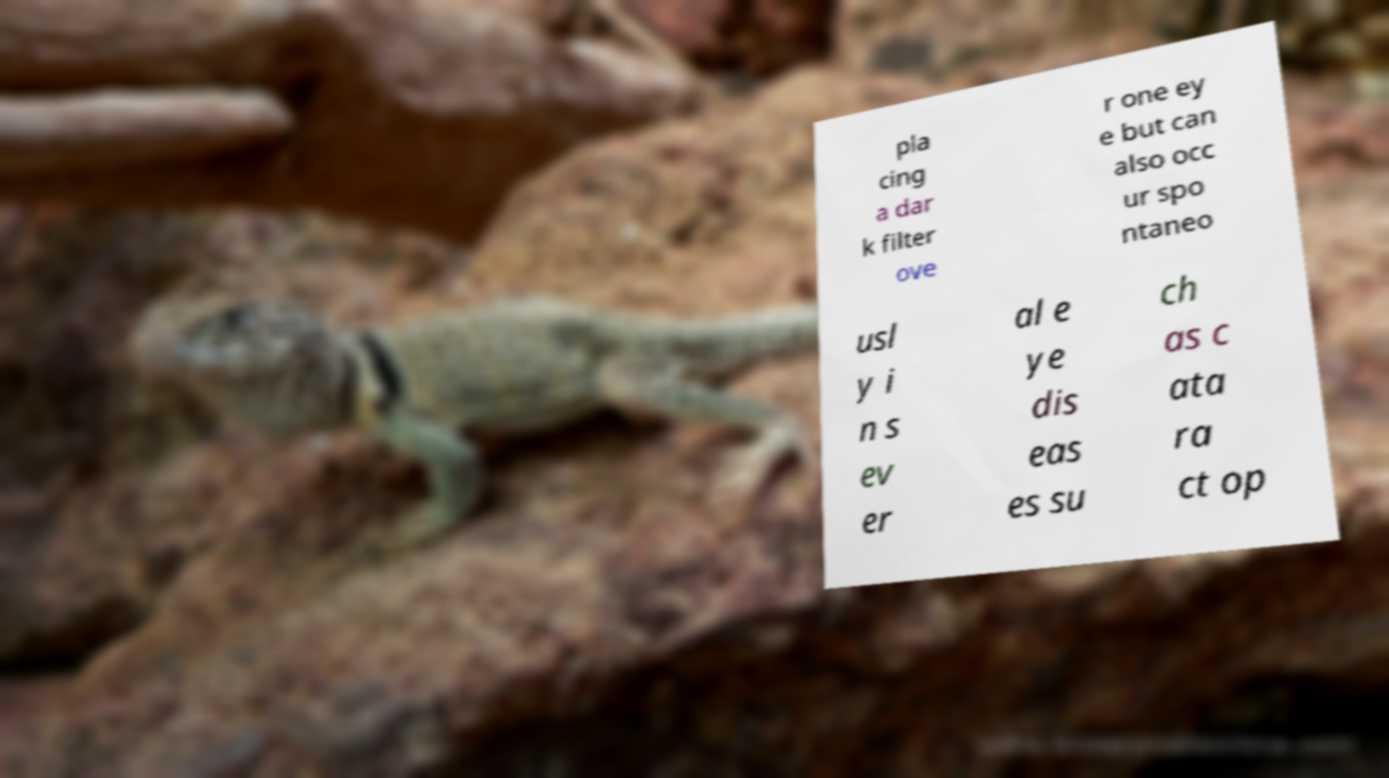There's text embedded in this image that I need extracted. Can you transcribe it verbatim? pla cing a dar k filter ove r one ey e but can also occ ur spo ntaneo usl y i n s ev er al e ye dis eas es su ch as c ata ra ct op 